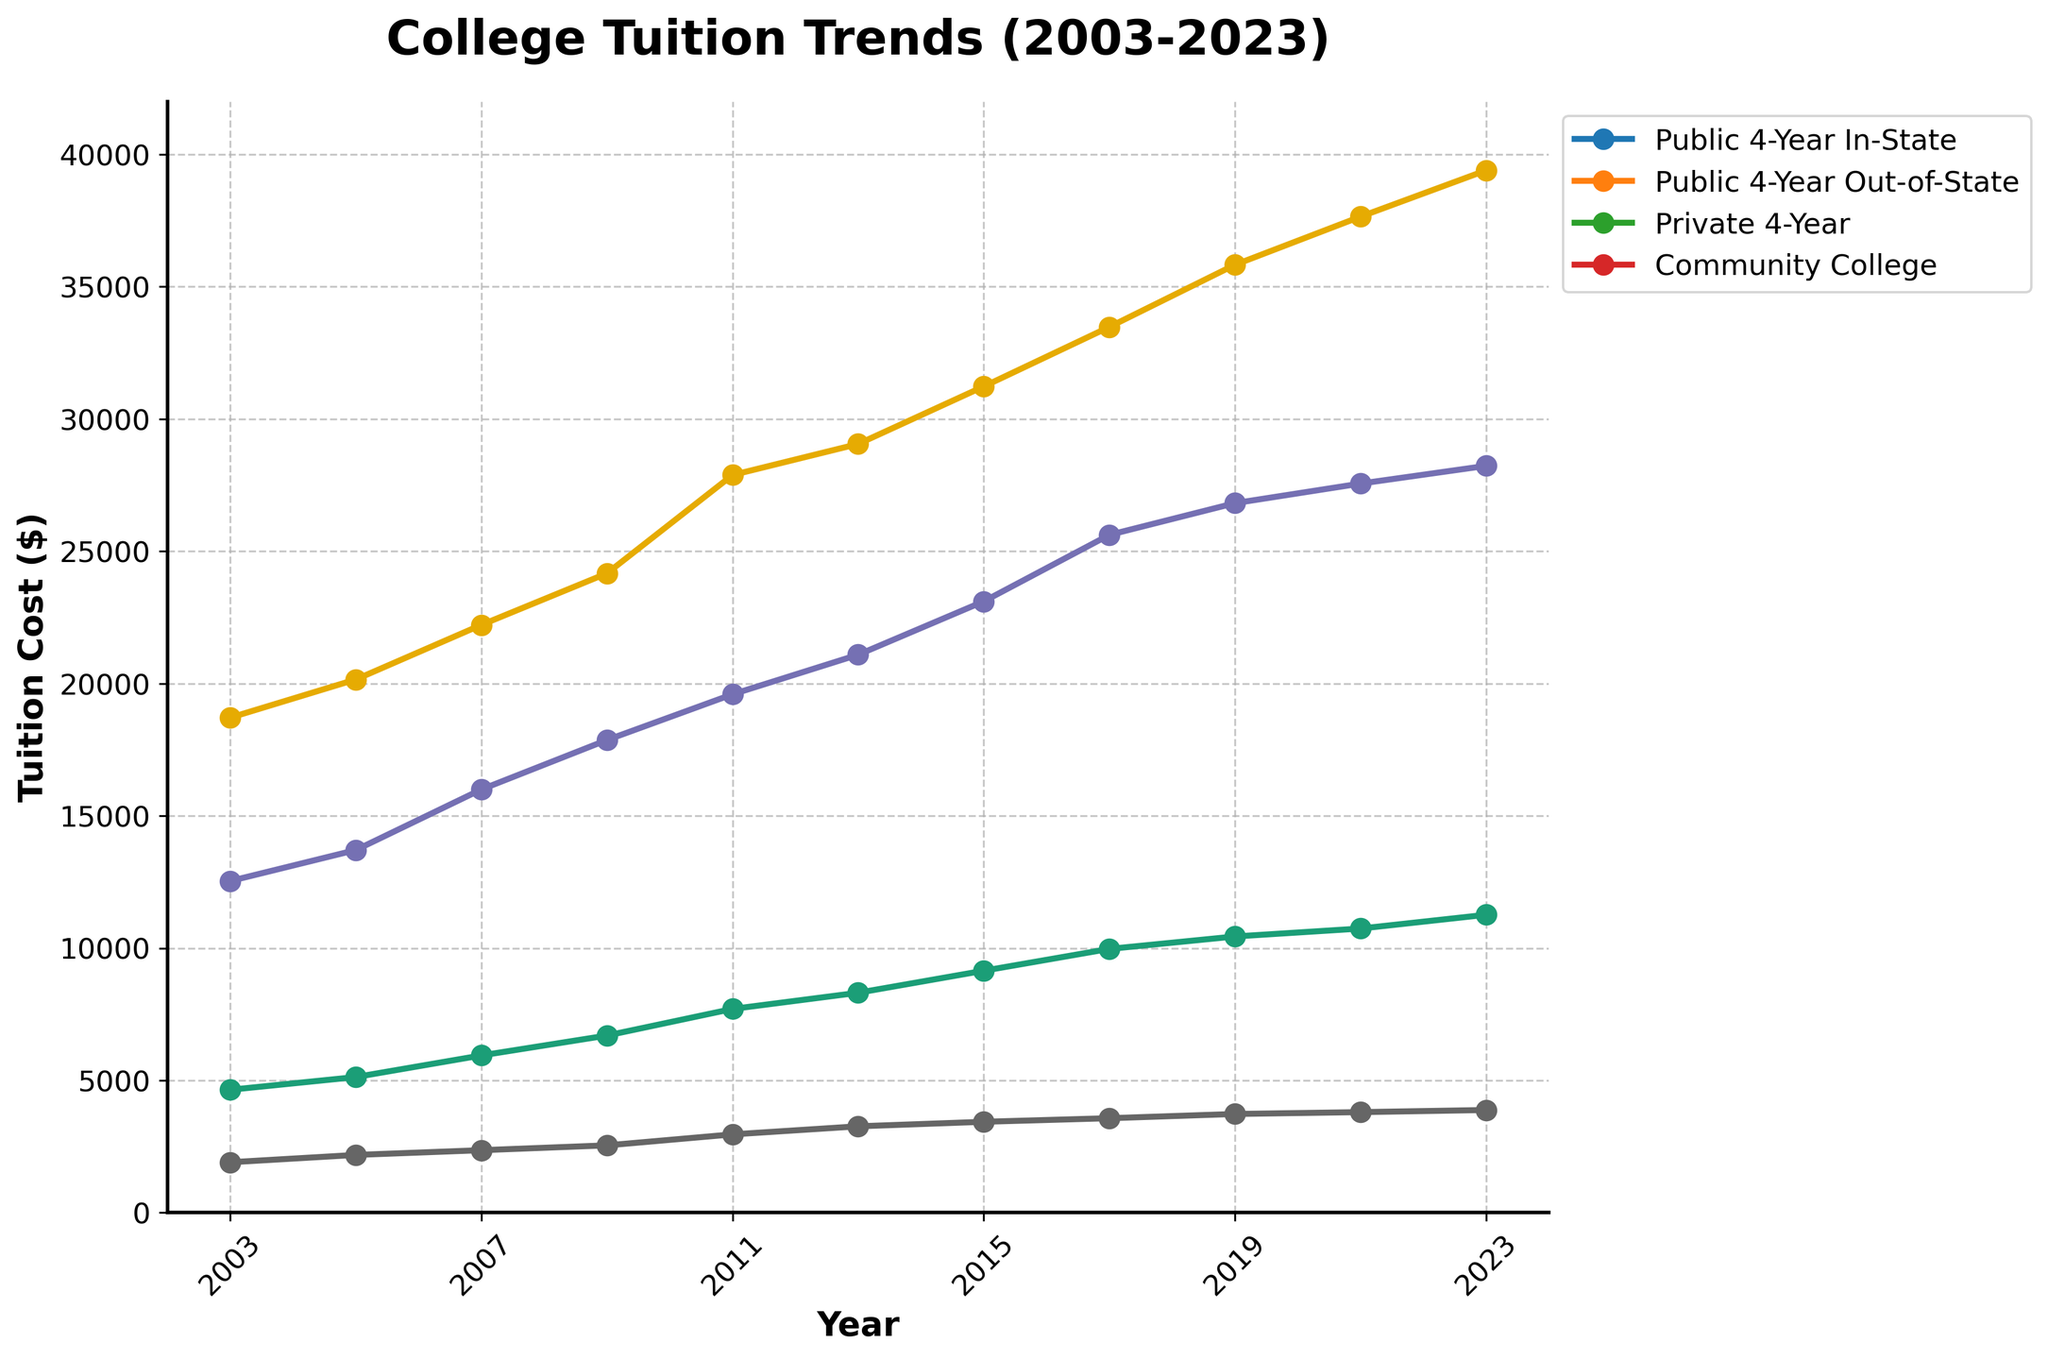What's the increase in tuition costs for Public 4-Year In-State institutions from 2003 to 2023? In 2003, the tuition cost for Public 4-Year In-State institutions was $4645, and in 2023 it was $11260. The increase can be calculated as $11260 - $4645. Therefore, the increase is $6615.
Answer: $6615 Which type of institution had the highest tuition cost in 2023? Looking at the data for 2023, the Private 4-Year institutions had the highest tuition cost of $39400.
Answer: Private 4-Year How did the tuition cost for Community Colleges change from 2015 to 2023? In 2015, the tuition cost for Community Colleges was $3435, and in 2023 it was $3880. The change is $3880 - $3435, which equals $445.
Answer: $445 What's the difference in tuition costs between Public 4-Year Out-of-State and Public 4-Year In-State institutions in 2023? The tuition cost for Public 4-Year Out-of-State institutions in 2023 was $28230, and for Public 4-Year In-State it was $11260. The difference is $28230 - $11260, equaling $16970.
Answer: $16970 Which type of institution had the most consistent increase in tuition over the 20 years? By visually inspecting the trend lines, all types of institutions have increasing trends. However, the Community Colleges show a relatively steady and linear increase compared to the more fluctuating trends of Public and Private 4-Year institutions.
Answer: Community Colleges How does the 2023 tuition cost for Public 4-Year Out-of-State compare to the 2003 tuition cost for Private 4-Year institutions? The 2023 tuition cost for Public 4-Year Out-of-State is $28230, while the 2003 tuition cost for Private 4-Year institutions was $18710. The Public 4-Year Out-of-State cost in 2023 is higher by $28230 - $18710, which is $9520.
Answer: $9520 higher During which period did Private 4-Year institutions see the largest increase in tuition costs? The data shows that the tuition for Private 4-Year institutions increased most significantly between 2009 and 2011, going from $24166 to $27883. The increase is $27883 - $24166, equaling $3717.
Answer: 2009-2011 Is the trend of Public 4-Year In-State tuition costs increasing or decreasing? By looking at the line chart, it's evident that the tuition costs for Public 4-Year In-State institutions have been increasing steadily over the years.
Answer: Increasing Compare the 2005 tuition costs for Private 4-Year institutions with Public 4-Year Out-of-State institutions. In 2005, the tuition cost for Private 4-Year institutions was $20154, and for Public 4-Year Out-of-State institutions it was $13706. Therefore, Private 4-Year institutions had a higher cost by $20154 - $13706, which is $6448.
Answer: $6448 higher 